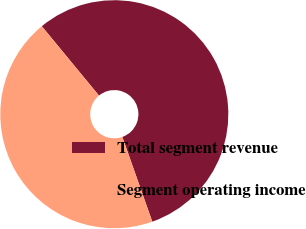Convert chart to OTSL. <chart><loc_0><loc_0><loc_500><loc_500><pie_chart><fcel>Total segment revenue<fcel>Segment operating income<nl><fcel>55.56%<fcel>44.44%<nl></chart> 